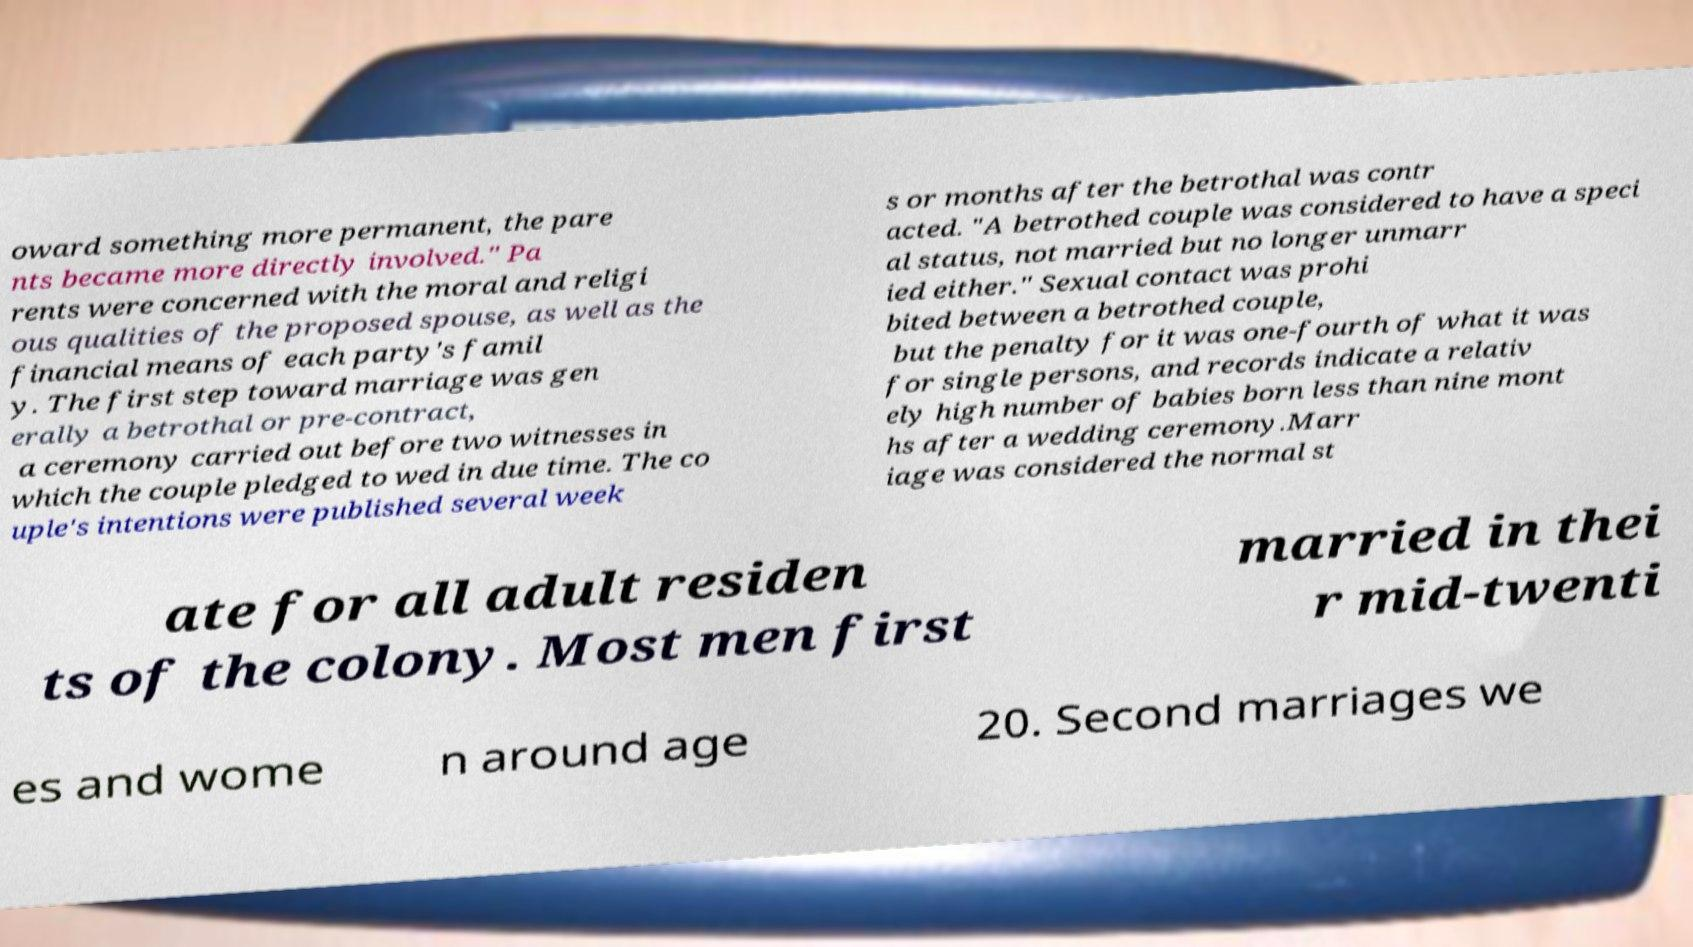For documentation purposes, I need the text within this image transcribed. Could you provide that? oward something more permanent, the pare nts became more directly involved." Pa rents were concerned with the moral and religi ous qualities of the proposed spouse, as well as the financial means of each party's famil y. The first step toward marriage was gen erally a betrothal or pre-contract, a ceremony carried out before two witnesses in which the couple pledged to wed in due time. The co uple's intentions were published several week s or months after the betrothal was contr acted. "A betrothed couple was considered to have a speci al status, not married but no longer unmarr ied either." Sexual contact was prohi bited between a betrothed couple, but the penalty for it was one-fourth of what it was for single persons, and records indicate a relativ ely high number of babies born less than nine mont hs after a wedding ceremony.Marr iage was considered the normal st ate for all adult residen ts of the colony. Most men first married in thei r mid-twenti es and wome n around age 20. Second marriages we 